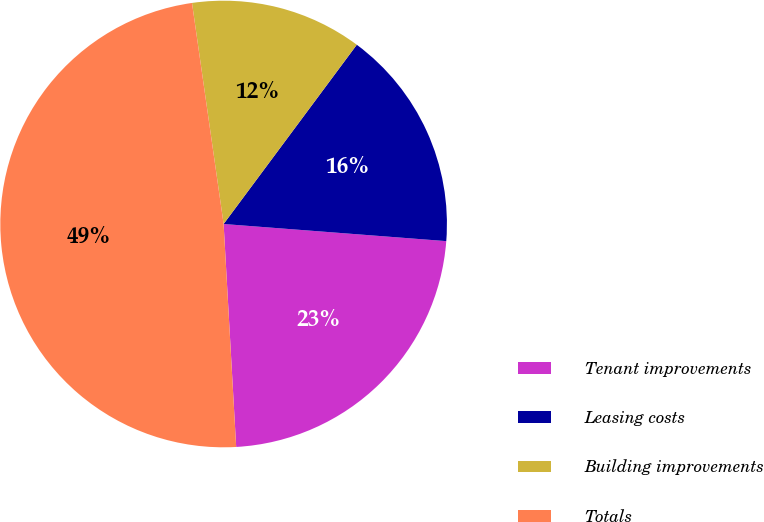<chart> <loc_0><loc_0><loc_500><loc_500><pie_chart><fcel>Tenant improvements<fcel>Leasing costs<fcel>Building improvements<fcel>Totals<nl><fcel>22.88%<fcel>16.05%<fcel>12.43%<fcel>48.63%<nl></chart> 